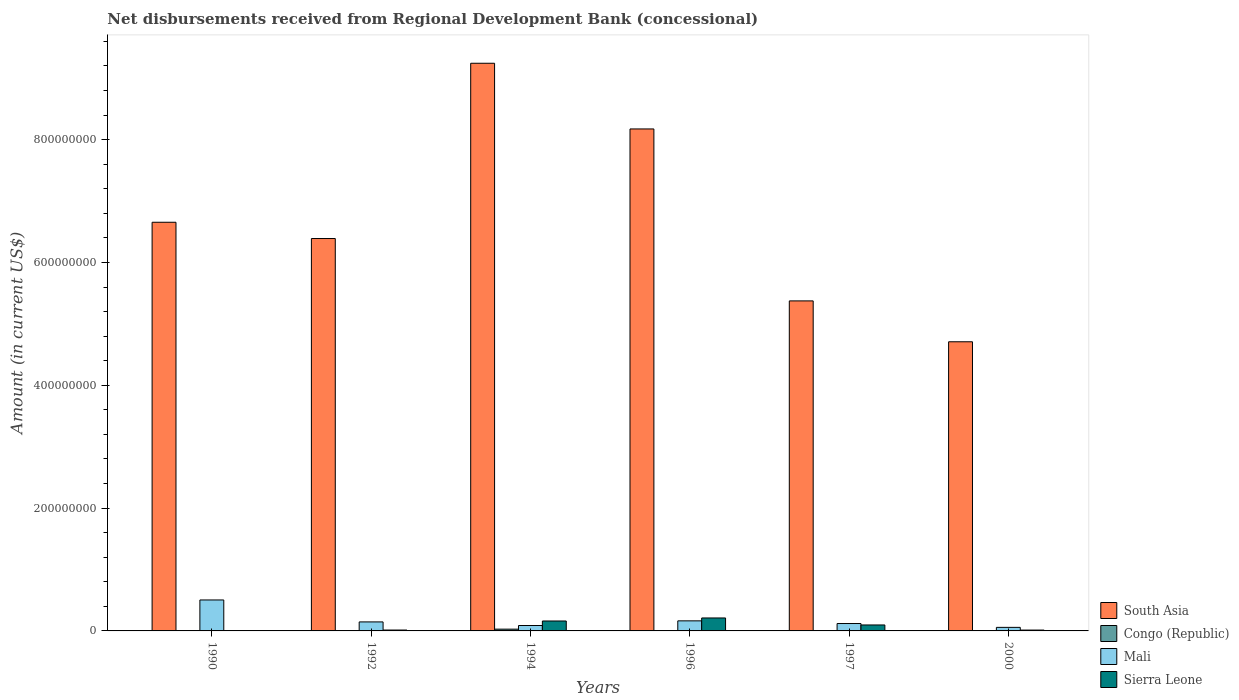Are the number of bars on each tick of the X-axis equal?
Make the answer very short. No. How many bars are there on the 3rd tick from the right?
Keep it short and to the point. 3. What is the amount of disbursements received from Regional Development Bank in South Asia in 1994?
Offer a terse response. 9.24e+08. Across all years, what is the maximum amount of disbursements received from Regional Development Bank in Congo (Republic)?
Give a very brief answer. 2.88e+06. Across all years, what is the minimum amount of disbursements received from Regional Development Bank in South Asia?
Make the answer very short. 4.71e+08. In which year was the amount of disbursements received from Regional Development Bank in Congo (Republic) maximum?
Your response must be concise. 1994. What is the total amount of disbursements received from Regional Development Bank in Mali in the graph?
Offer a terse response. 1.08e+08. What is the difference between the amount of disbursements received from Regional Development Bank in Sierra Leone in 1992 and that in 1996?
Give a very brief answer. -1.97e+07. What is the difference between the amount of disbursements received from Regional Development Bank in Mali in 1992 and the amount of disbursements received from Regional Development Bank in Congo (Republic) in 1997?
Provide a short and direct response. 1.47e+07. What is the average amount of disbursements received from Regional Development Bank in Mali per year?
Keep it short and to the point. 1.80e+07. In the year 1992, what is the difference between the amount of disbursements received from Regional Development Bank in Sierra Leone and amount of disbursements received from Regional Development Bank in South Asia?
Provide a short and direct response. -6.38e+08. In how many years, is the amount of disbursements received from Regional Development Bank in South Asia greater than 800000000 US$?
Your answer should be compact. 2. What is the ratio of the amount of disbursements received from Regional Development Bank in Sierra Leone in 1996 to that in 2000?
Provide a succinct answer. 15.21. Is the difference between the amount of disbursements received from Regional Development Bank in Sierra Leone in 1992 and 1996 greater than the difference between the amount of disbursements received from Regional Development Bank in South Asia in 1992 and 1996?
Your answer should be very brief. Yes. What is the difference between the highest and the second highest amount of disbursements received from Regional Development Bank in Sierra Leone?
Your answer should be compact. 4.92e+06. What is the difference between the highest and the lowest amount of disbursements received from Regional Development Bank in Congo (Republic)?
Provide a short and direct response. 2.88e+06. In how many years, is the amount of disbursements received from Regional Development Bank in Mali greater than the average amount of disbursements received from Regional Development Bank in Mali taken over all years?
Provide a short and direct response. 1. Is it the case that in every year, the sum of the amount of disbursements received from Regional Development Bank in South Asia and amount of disbursements received from Regional Development Bank in Congo (Republic) is greater than the amount of disbursements received from Regional Development Bank in Mali?
Ensure brevity in your answer.  Yes. How many bars are there?
Provide a short and direct response. 19. Are all the bars in the graph horizontal?
Offer a terse response. No. How many years are there in the graph?
Offer a terse response. 6. Does the graph contain any zero values?
Your response must be concise. Yes. Does the graph contain grids?
Keep it short and to the point. No. Where does the legend appear in the graph?
Your answer should be very brief. Bottom right. How many legend labels are there?
Provide a succinct answer. 4. How are the legend labels stacked?
Your answer should be compact. Vertical. What is the title of the graph?
Provide a succinct answer. Net disbursements received from Regional Development Bank (concessional). What is the label or title of the X-axis?
Offer a very short reply. Years. What is the label or title of the Y-axis?
Your answer should be very brief. Amount (in current US$). What is the Amount (in current US$) of South Asia in 1990?
Give a very brief answer. 6.65e+08. What is the Amount (in current US$) of Congo (Republic) in 1990?
Provide a succinct answer. 4.16e+05. What is the Amount (in current US$) of Mali in 1990?
Your response must be concise. 5.04e+07. What is the Amount (in current US$) in Sierra Leone in 1990?
Offer a very short reply. 0. What is the Amount (in current US$) in South Asia in 1992?
Your response must be concise. 6.39e+08. What is the Amount (in current US$) of Congo (Republic) in 1992?
Your response must be concise. 0. What is the Amount (in current US$) of Mali in 1992?
Offer a terse response. 1.47e+07. What is the Amount (in current US$) in Sierra Leone in 1992?
Provide a short and direct response. 1.43e+06. What is the Amount (in current US$) in South Asia in 1994?
Ensure brevity in your answer.  9.24e+08. What is the Amount (in current US$) of Congo (Republic) in 1994?
Ensure brevity in your answer.  2.88e+06. What is the Amount (in current US$) of Mali in 1994?
Make the answer very short. 8.81e+06. What is the Amount (in current US$) in Sierra Leone in 1994?
Provide a succinct answer. 1.62e+07. What is the Amount (in current US$) of South Asia in 1996?
Your answer should be compact. 8.17e+08. What is the Amount (in current US$) in Congo (Republic) in 1996?
Your response must be concise. 0. What is the Amount (in current US$) in Mali in 1996?
Offer a very short reply. 1.64e+07. What is the Amount (in current US$) in Sierra Leone in 1996?
Offer a very short reply. 2.11e+07. What is the Amount (in current US$) of South Asia in 1997?
Offer a terse response. 5.37e+08. What is the Amount (in current US$) of Mali in 1997?
Ensure brevity in your answer.  1.21e+07. What is the Amount (in current US$) in Sierra Leone in 1997?
Offer a very short reply. 9.70e+06. What is the Amount (in current US$) in South Asia in 2000?
Your answer should be very brief. 4.71e+08. What is the Amount (in current US$) in Congo (Republic) in 2000?
Keep it short and to the point. 0. What is the Amount (in current US$) of Mali in 2000?
Give a very brief answer. 5.78e+06. What is the Amount (in current US$) of Sierra Leone in 2000?
Provide a succinct answer. 1.39e+06. Across all years, what is the maximum Amount (in current US$) in South Asia?
Your answer should be very brief. 9.24e+08. Across all years, what is the maximum Amount (in current US$) in Congo (Republic)?
Give a very brief answer. 2.88e+06. Across all years, what is the maximum Amount (in current US$) in Mali?
Give a very brief answer. 5.04e+07. Across all years, what is the maximum Amount (in current US$) in Sierra Leone?
Offer a very short reply. 2.11e+07. Across all years, what is the minimum Amount (in current US$) in South Asia?
Keep it short and to the point. 4.71e+08. Across all years, what is the minimum Amount (in current US$) in Mali?
Your answer should be compact. 5.78e+06. What is the total Amount (in current US$) in South Asia in the graph?
Your answer should be compact. 4.05e+09. What is the total Amount (in current US$) of Congo (Republic) in the graph?
Provide a succinct answer. 3.29e+06. What is the total Amount (in current US$) of Mali in the graph?
Ensure brevity in your answer.  1.08e+08. What is the total Amount (in current US$) in Sierra Leone in the graph?
Your response must be concise. 4.98e+07. What is the difference between the Amount (in current US$) in South Asia in 1990 and that in 1992?
Give a very brief answer. 2.65e+07. What is the difference between the Amount (in current US$) of Mali in 1990 and that in 1992?
Give a very brief answer. 3.57e+07. What is the difference between the Amount (in current US$) of South Asia in 1990 and that in 1994?
Provide a short and direct response. -2.59e+08. What is the difference between the Amount (in current US$) in Congo (Republic) in 1990 and that in 1994?
Offer a terse response. -2.46e+06. What is the difference between the Amount (in current US$) of Mali in 1990 and that in 1994?
Your answer should be compact. 4.16e+07. What is the difference between the Amount (in current US$) of South Asia in 1990 and that in 1996?
Make the answer very short. -1.52e+08. What is the difference between the Amount (in current US$) in Mali in 1990 and that in 1996?
Your answer should be very brief. 3.40e+07. What is the difference between the Amount (in current US$) of South Asia in 1990 and that in 1997?
Your answer should be compact. 1.28e+08. What is the difference between the Amount (in current US$) in Mali in 1990 and that in 1997?
Make the answer very short. 3.84e+07. What is the difference between the Amount (in current US$) in South Asia in 1990 and that in 2000?
Your answer should be very brief. 1.95e+08. What is the difference between the Amount (in current US$) of Mali in 1990 and that in 2000?
Give a very brief answer. 4.46e+07. What is the difference between the Amount (in current US$) of South Asia in 1992 and that in 1994?
Your answer should be compact. -2.85e+08. What is the difference between the Amount (in current US$) of Mali in 1992 and that in 1994?
Your response must be concise. 5.86e+06. What is the difference between the Amount (in current US$) in Sierra Leone in 1992 and that in 1994?
Provide a succinct answer. -1.47e+07. What is the difference between the Amount (in current US$) of South Asia in 1992 and that in 1996?
Offer a very short reply. -1.78e+08. What is the difference between the Amount (in current US$) of Mali in 1992 and that in 1996?
Make the answer very short. -1.73e+06. What is the difference between the Amount (in current US$) of Sierra Leone in 1992 and that in 1996?
Your response must be concise. -1.97e+07. What is the difference between the Amount (in current US$) in South Asia in 1992 and that in 1997?
Ensure brevity in your answer.  1.02e+08. What is the difference between the Amount (in current US$) in Mali in 1992 and that in 1997?
Provide a short and direct response. 2.62e+06. What is the difference between the Amount (in current US$) of Sierra Leone in 1992 and that in 1997?
Ensure brevity in your answer.  -8.26e+06. What is the difference between the Amount (in current US$) of South Asia in 1992 and that in 2000?
Give a very brief answer. 1.68e+08. What is the difference between the Amount (in current US$) in Mali in 1992 and that in 2000?
Keep it short and to the point. 8.89e+06. What is the difference between the Amount (in current US$) of Sierra Leone in 1992 and that in 2000?
Provide a succinct answer. 4.40e+04. What is the difference between the Amount (in current US$) in South Asia in 1994 and that in 1996?
Provide a short and direct response. 1.07e+08. What is the difference between the Amount (in current US$) of Mali in 1994 and that in 1996?
Your answer should be very brief. -7.59e+06. What is the difference between the Amount (in current US$) of Sierra Leone in 1994 and that in 1996?
Provide a succinct answer. -4.92e+06. What is the difference between the Amount (in current US$) of South Asia in 1994 and that in 1997?
Your answer should be compact. 3.87e+08. What is the difference between the Amount (in current US$) of Mali in 1994 and that in 1997?
Provide a succinct answer. -3.24e+06. What is the difference between the Amount (in current US$) in Sierra Leone in 1994 and that in 1997?
Provide a succinct answer. 6.48e+06. What is the difference between the Amount (in current US$) of South Asia in 1994 and that in 2000?
Your response must be concise. 4.54e+08. What is the difference between the Amount (in current US$) of Mali in 1994 and that in 2000?
Provide a short and direct response. 3.03e+06. What is the difference between the Amount (in current US$) of Sierra Leone in 1994 and that in 2000?
Offer a terse response. 1.48e+07. What is the difference between the Amount (in current US$) of South Asia in 1996 and that in 1997?
Offer a terse response. 2.80e+08. What is the difference between the Amount (in current US$) in Mali in 1996 and that in 1997?
Offer a very short reply. 4.34e+06. What is the difference between the Amount (in current US$) of Sierra Leone in 1996 and that in 1997?
Make the answer very short. 1.14e+07. What is the difference between the Amount (in current US$) of South Asia in 1996 and that in 2000?
Keep it short and to the point. 3.47e+08. What is the difference between the Amount (in current US$) of Mali in 1996 and that in 2000?
Offer a very short reply. 1.06e+07. What is the difference between the Amount (in current US$) of Sierra Leone in 1996 and that in 2000?
Provide a succinct answer. 1.97e+07. What is the difference between the Amount (in current US$) of South Asia in 1997 and that in 2000?
Provide a succinct answer. 6.66e+07. What is the difference between the Amount (in current US$) in Mali in 1997 and that in 2000?
Make the answer very short. 6.28e+06. What is the difference between the Amount (in current US$) in Sierra Leone in 1997 and that in 2000?
Your answer should be very brief. 8.31e+06. What is the difference between the Amount (in current US$) in South Asia in 1990 and the Amount (in current US$) in Mali in 1992?
Ensure brevity in your answer.  6.51e+08. What is the difference between the Amount (in current US$) of South Asia in 1990 and the Amount (in current US$) of Sierra Leone in 1992?
Provide a succinct answer. 6.64e+08. What is the difference between the Amount (in current US$) in Congo (Republic) in 1990 and the Amount (in current US$) in Mali in 1992?
Offer a very short reply. -1.43e+07. What is the difference between the Amount (in current US$) of Congo (Republic) in 1990 and the Amount (in current US$) of Sierra Leone in 1992?
Your answer should be very brief. -1.02e+06. What is the difference between the Amount (in current US$) in Mali in 1990 and the Amount (in current US$) in Sierra Leone in 1992?
Your response must be concise. 4.90e+07. What is the difference between the Amount (in current US$) in South Asia in 1990 and the Amount (in current US$) in Congo (Republic) in 1994?
Give a very brief answer. 6.63e+08. What is the difference between the Amount (in current US$) in South Asia in 1990 and the Amount (in current US$) in Mali in 1994?
Provide a short and direct response. 6.57e+08. What is the difference between the Amount (in current US$) of South Asia in 1990 and the Amount (in current US$) of Sierra Leone in 1994?
Provide a short and direct response. 6.49e+08. What is the difference between the Amount (in current US$) in Congo (Republic) in 1990 and the Amount (in current US$) in Mali in 1994?
Make the answer very short. -8.39e+06. What is the difference between the Amount (in current US$) in Congo (Republic) in 1990 and the Amount (in current US$) in Sierra Leone in 1994?
Make the answer very short. -1.58e+07. What is the difference between the Amount (in current US$) of Mali in 1990 and the Amount (in current US$) of Sierra Leone in 1994?
Ensure brevity in your answer.  3.42e+07. What is the difference between the Amount (in current US$) of South Asia in 1990 and the Amount (in current US$) of Mali in 1996?
Provide a short and direct response. 6.49e+08. What is the difference between the Amount (in current US$) in South Asia in 1990 and the Amount (in current US$) in Sierra Leone in 1996?
Your answer should be compact. 6.44e+08. What is the difference between the Amount (in current US$) of Congo (Republic) in 1990 and the Amount (in current US$) of Mali in 1996?
Make the answer very short. -1.60e+07. What is the difference between the Amount (in current US$) of Congo (Republic) in 1990 and the Amount (in current US$) of Sierra Leone in 1996?
Your response must be concise. -2.07e+07. What is the difference between the Amount (in current US$) in Mali in 1990 and the Amount (in current US$) in Sierra Leone in 1996?
Provide a short and direct response. 2.93e+07. What is the difference between the Amount (in current US$) in South Asia in 1990 and the Amount (in current US$) in Mali in 1997?
Your response must be concise. 6.53e+08. What is the difference between the Amount (in current US$) in South Asia in 1990 and the Amount (in current US$) in Sierra Leone in 1997?
Your answer should be very brief. 6.56e+08. What is the difference between the Amount (in current US$) in Congo (Republic) in 1990 and the Amount (in current US$) in Mali in 1997?
Ensure brevity in your answer.  -1.16e+07. What is the difference between the Amount (in current US$) of Congo (Republic) in 1990 and the Amount (in current US$) of Sierra Leone in 1997?
Offer a very short reply. -9.28e+06. What is the difference between the Amount (in current US$) of Mali in 1990 and the Amount (in current US$) of Sierra Leone in 1997?
Your answer should be compact. 4.07e+07. What is the difference between the Amount (in current US$) in South Asia in 1990 and the Amount (in current US$) in Mali in 2000?
Provide a succinct answer. 6.60e+08. What is the difference between the Amount (in current US$) in South Asia in 1990 and the Amount (in current US$) in Sierra Leone in 2000?
Keep it short and to the point. 6.64e+08. What is the difference between the Amount (in current US$) of Congo (Republic) in 1990 and the Amount (in current US$) of Mali in 2000?
Your answer should be very brief. -5.36e+06. What is the difference between the Amount (in current US$) of Congo (Republic) in 1990 and the Amount (in current US$) of Sierra Leone in 2000?
Give a very brief answer. -9.71e+05. What is the difference between the Amount (in current US$) of Mali in 1990 and the Amount (in current US$) of Sierra Leone in 2000?
Offer a very short reply. 4.90e+07. What is the difference between the Amount (in current US$) of South Asia in 1992 and the Amount (in current US$) of Congo (Republic) in 1994?
Your answer should be very brief. 6.36e+08. What is the difference between the Amount (in current US$) in South Asia in 1992 and the Amount (in current US$) in Mali in 1994?
Make the answer very short. 6.30e+08. What is the difference between the Amount (in current US$) in South Asia in 1992 and the Amount (in current US$) in Sierra Leone in 1994?
Your answer should be compact. 6.23e+08. What is the difference between the Amount (in current US$) in Mali in 1992 and the Amount (in current US$) in Sierra Leone in 1994?
Offer a terse response. -1.51e+06. What is the difference between the Amount (in current US$) of South Asia in 1992 and the Amount (in current US$) of Mali in 1996?
Offer a terse response. 6.23e+08. What is the difference between the Amount (in current US$) of South Asia in 1992 and the Amount (in current US$) of Sierra Leone in 1996?
Give a very brief answer. 6.18e+08. What is the difference between the Amount (in current US$) in Mali in 1992 and the Amount (in current US$) in Sierra Leone in 1996?
Make the answer very short. -6.43e+06. What is the difference between the Amount (in current US$) in South Asia in 1992 and the Amount (in current US$) in Mali in 1997?
Your answer should be compact. 6.27e+08. What is the difference between the Amount (in current US$) of South Asia in 1992 and the Amount (in current US$) of Sierra Leone in 1997?
Your answer should be very brief. 6.29e+08. What is the difference between the Amount (in current US$) of Mali in 1992 and the Amount (in current US$) of Sierra Leone in 1997?
Your answer should be compact. 4.97e+06. What is the difference between the Amount (in current US$) in South Asia in 1992 and the Amount (in current US$) in Mali in 2000?
Your answer should be compact. 6.33e+08. What is the difference between the Amount (in current US$) of South Asia in 1992 and the Amount (in current US$) of Sierra Leone in 2000?
Make the answer very short. 6.38e+08. What is the difference between the Amount (in current US$) in Mali in 1992 and the Amount (in current US$) in Sierra Leone in 2000?
Ensure brevity in your answer.  1.33e+07. What is the difference between the Amount (in current US$) of South Asia in 1994 and the Amount (in current US$) of Mali in 1996?
Your response must be concise. 9.08e+08. What is the difference between the Amount (in current US$) of South Asia in 1994 and the Amount (in current US$) of Sierra Leone in 1996?
Offer a terse response. 9.03e+08. What is the difference between the Amount (in current US$) in Congo (Republic) in 1994 and the Amount (in current US$) in Mali in 1996?
Offer a very short reply. -1.35e+07. What is the difference between the Amount (in current US$) of Congo (Republic) in 1994 and the Amount (in current US$) of Sierra Leone in 1996?
Give a very brief answer. -1.82e+07. What is the difference between the Amount (in current US$) of Mali in 1994 and the Amount (in current US$) of Sierra Leone in 1996?
Make the answer very short. -1.23e+07. What is the difference between the Amount (in current US$) in South Asia in 1994 and the Amount (in current US$) in Mali in 1997?
Your answer should be compact. 9.12e+08. What is the difference between the Amount (in current US$) in South Asia in 1994 and the Amount (in current US$) in Sierra Leone in 1997?
Your response must be concise. 9.15e+08. What is the difference between the Amount (in current US$) in Congo (Republic) in 1994 and the Amount (in current US$) in Mali in 1997?
Ensure brevity in your answer.  -9.17e+06. What is the difference between the Amount (in current US$) of Congo (Republic) in 1994 and the Amount (in current US$) of Sierra Leone in 1997?
Give a very brief answer. -6.82e+06. What is the difference between the Amount (in current US$) of Mali in 1994 and the Amount (in current US$) of Sierra Leone in 1997?
Your response must be concise. -8.88e+05. What is the difference between the Amount (in current US$) in South Asia in 1994 and the Amount (in current US$) in Mali in 2000?
Make the answer very short. 9.19e+08. What is the difference between the Amount (in current US$) of South Asia in 1994 and the Amount (in current US$) of Sierra Leone in 2000?
Give a very brief answer. 9.23e+08. What is the difference between the Amount (in current US$) in Congo (Republic) in 1994 and the Amount (in current US$) in Mali in 2000?
Ensure brevity in your answer.  -2.90e+06. What is the difference between the Amount (in current US$) of Congo (Republic) in 1994 and the Amount (in current US$) of Sierra Leone in 2000?
Your answer should be compact. 1.49e+06. What is the difference between the Amount (in current US$) in Mali in 1994 and the Amount (in current US$) in Sierra Leone in 2000?
Your response must be concise. 7.42e+06. What is the difference between the Amount (in current US$) in South Asia in 1996 and the Amount (in current US$) in Mali in 1997?
Ensure brevity in your answer.  8.05e+08. What is the difference between the Amount (in current US$) in South Asia in 1996 and the Amount (in current US$) in Sierra Leone in 1997?
Your response must be concise. 8.08e+08. What is the difference between the Amount (in current US$) of Mali in 1996 and the Amount (in current US$) of Sierra Leone in 1997?
Provide a succinct answer. 6.70e+06. What is the difference between the Amount (in current US$) of South Asia in 1996 and the Amount (in current US$) of Mali in 2000?
Offer a very short reply. 8.12e+08. What is the difference between the Amount (in current US$) of South Asia in 1996 and the Amount (in current US$) of Sierra Leone in 2000?
Keep it short and to the point. 8.16e+08. What is the difference between the Amount (in current US$) in Mali in 1996 and the Amount (in current US$) in Sierra Leone in 2000?
Give a very brief answer. 1.50e+07. What is the difference between the Amount (in current US$) in South Asia in 1997 and the Amount (in current US$) in Mali in 2000?
Your answer should be compact. 5.32e+08. What is the difference between the Amount (in current US$) of South Asia in 1997 and the Amount (in current US$) of Sierra Leone in 2000?
Give a very brief answer. 5.36e+08. What is the difference between the Amount (in current US$) of Mali in 1997 and the Amount (in current US$) of Sierra Leone in 2000?
Give a very brief answer. 1.07e+07. What is the average Amount (in current US$) in South Asia per year?
Keep it short and to the point. 6.76e+08. What is the average Amount (in current US$) in Congo (Republic) per year?
Your answer should be compact. 5.49e+05. What is the average Amount (in current US$) of Mali per year?
Offer a very short reply. 1.80e+07. What is the average Amount (in current US$) in Sierra Leone per year?
Make the answer very short. 8.30e+06. In the year 1990, what is the difference between the Amount (in current US$) in South Asia and Amount (in current US$) in Congo (Republic)?
Offer a terse response. 6.65e+08. In the year 1990, what is the difference between the Amount (in current US$) in South Asia and Amount (in current US$) in Mali?
Offer a terse response. 6.15e+08. In the year 1990, what is the difference between the Amount (in current US$) in Congo (Republic) and Amount (in current US$) in Mali?
Provide a succinct answer. -5.00e+07. In the year 1992, what is the difference between the Amount (in current US$) of South Asia and Amount (in current US$) of Mali?
Provide a short and direct response. 6.24e+08. In the year 1992, what is the difference between the Amount (in current US$) of South Asia and Amount (in current US$) of Sierra Leone?
Give a very brief answer. 6.38e+08. In the year 1992, what is the difference between the Amount (in current US$) of Mali and Amount (in current US$) of Sierra Leone?
Offer a terse response. 1.32e+07. In the year 1994, what is the difference between the Amount (in current US$) in South Asia and Amount (in current US$) in Congo (Republic)?
Offer a very short reply. 9.22e+08. In the year 1994, what is the difference between the Amount (in current US$) in South Asia and Amount (in current US$) in Mali?
Offer a very short reply. 9.16e+08. In the year 1994, what is the difference between the Amount (in current US$) in South Asia and Amount (in current US$) in Sierra Leone?
Provide a short and direct response. 9.08e+08. In the year 1994, what is the difference between the Amount (in current US$) of Congo (Republic) and Amount (in current US$) of Mali?
Provide a succinct answer. -5.93e+06. In the year 1994, what is the difference between the Amount (in current US$) of Congo (Republic) and Amount (in current US$) of Sierra Leone?
Your answer should be compact. -1.33e+07. In the year 1994, what is the difference between the Amount (in current US$) of Mali and Amount (in current US$) of Sierra Leone?
Offer a very short reply. -7.37e+06. In the year 1996, what is the difference between the Amount (in current US$) in South Asia and Amount (in current US$) in Mali?
Offer a very short reply. 8.01e+08. In the year 1996, what is the difference between the Amount (in current US$) in South Asia and Amount (in current US$) in Sierra Leone?
Your answer should be compact. 7.96e+08. In the year 1996, what is the difference between the Amount (in current US$) of Mali and Amount (in current US$) of Sierra Leone?
Provide a succinct answer. -4.71e+06. In the year 1997, what is the difference between the Amount (in current US$) in South Asia and Amount (in current US$) in Mali?
Your answer should be very brief. 5.25e+08. In the year 1997, what is the difference between the Amount (in current US$) of South Asia and Amount (in current US$) of Sierra Leone?
Make the answer very short. 5.28e+08. In the year 1997, what is the difference between the Amount (in current US$) in Mali and Amount (in current US$) in Sierra Leone?
Provide a short and direct response. 2.36e+06. In the year 2000, what is the difference between the Amount (in current US$) in South Asia and Amount (in current US$) in Mali?
Provide a short and direct response. 4.65e+08. In the year 2000, what is the difference between the Amount (in current US$) of South Asia and Amount (in current US$) of Sierra Leone?
Provide a succinct answer. 4.69e+08. In the year 2000, what is the difference between the Amount (in current US$) in Mali and Amount (in current US$) in Sierra Leone?
Your response must be concise. 4.39e+06. What is the ratio of the Amount (in current US$) in South Asia in 1990 to that in 1992?
Ensure brevity in your answer.  1.04. What is the ratio of the Amount (in current US$) in Mali in 1990 to that in 1992?
Provide a succinct answer. 3.44. What is the ratio of the Amount (in current US$) of South Asia in 1990 to that in 1994?
Ensure brevity in your answer.  0.72. What is the ratio of the Amount (in current US$) of Congo (Republic) in 1990 to that in 1994?
Your answer should be very brief. 0.14. What is the ratio of the Amount (in current US$) of Mali in 1990 to that in 1994?
Your answer should be very brief. 5.72. What is the ratio of the Amount (in current US$) in South Asia in 1990 to that in 1996?
Your response must be concise. 0.81. What is the ratio of the Amount (in current US$) of Mali in 1990 to that in 1996?
Ensure brevity in your answer.  3.07. What is the ratio of the Amount (in current US$) in South Asia in 1990 to that in 1997?
Give a very brief answer. 1.24. What is the ratio of the Amount (in current US$) of Mali in 1990 to that in 1997?
Your response must be concise. 4.18. What is the ratio of the Amount (in current US$) of South Asia in 1990 to that in 2000?
Your answer should be compact. 1.41. What is the ratio of the Amount (in current US$) of Mali in 1990 to that in 2000?
Provide a short and direct response. 8.73. What is the ratio of the Amount (in current US$) of South Asia in 1992 to that in 1994?
Offer a terse response. 0.69. What is the ratio of the Amount (in current US$) in Mali in 1992 to that in 1994?
Offer a very short reply. 1.67. What is the ratio of the Amount (in current US$) in Sierra Leone in 1992 to that in 1994?
Offer a terse response. 0.09. What is the ratio of the Amount (in current US$) of South Asia in 1992 to that in 1996?
Your answer should be compact. 0.78. What is the ratio of the Amount (in current US$) in Mali in 1992 to that in 1996?
Ensure brevity in your answer.  0.89. What is the ratio of the Amount (in current US$) of Sierra Leone in 1992 to that in 1996?
Provide a short and direct response. 0.07. What is the ratio of the Amount (in current US$) of South Asia in 1992 to that in 1997?
Give a very brief answer. 1.19. What is the ratio of the Amount (in current US$) of Mali in 1992 to that in 1997?
Make the answer very short. 1.22. What is the ratio of the Amount (in current US$) of Sierra Leone in 1992 to that in 1997?
Give a very brief answer. 0.15. What is the ratio of the Amount (in current US$) of South Asia in 1992 to that in 2000?
Ensure brevity in your answer.  1.36. What is the ratio of the Amount (in current US$) of Mali in 1992 to that in 2000?
Keep it short and to the point. 2.54. What is the ratio of the Amount (in current US$) of Sierra Leone in 1992 to that in 2000?
Keep it short and to the point. 1.03. What is the ratio of the Amount (in current US$) of South Asia in 1994 to that in 1996?
Provide a short and direct response. 1.13. What is the ratio of the Amount (in current US$) in Mali in 1994 to that in 1996?
Offer a very short reply. 0.54. What is the ratio of the Amount (in current US$) of Sierra Leone in 1994 to that in 1996?
Give a very brief answer. 0.77. What is the ratio of the Amount (in current US$) of South Asia in 1994 to that in 1997?
Provide a short and direct response. 1.72. What is the ratio of the Amount (in current US$) in Mali in 1994 to that in 1997?
Give a very brief answer. 0.73. What is the ratio of the Amount (in current US$) in Sierra Leone in 1994 to that in 1997?
Ensure brevity in your answer.  1.67. What is the ratio of the Amount (in current US$) in South Asia in 1994 to that in 2000?
Provide a succinct answer. 1.96. What is the ratio of the Amount (in current US$) in Mali in 1994 to that in 2000?
Give a very brief answer. 1.52. What is the ratio of the Amount (in current US$) of Sierra Leone in 1994 to that in 2000?
Offer a terse response. 11.66. What is the ratio of the Amount (in current US$) of South Asia in 1996 to that in 1997?
Make the answer very short. 1.52. What is the ratio of the Amount (in current US$) in Mali in 1996 to that in 1997?
Provide a succinct answer. 1.36. What is the ratio of the Amount (in current US$) of Sierra Leone in 1996 to that in 1997?
Keep it short and to the point. 2.18. What is the ratio of the Amount (in current US$) in South Asia in 1996 to that in 2000?
Your answer should be compact. 1.74. What is the ratio of the Amount (in current US$) in Mali in 1996 to that in 2000?
Your answer should be very brief. 2.84. What is the ratio of the Amount (in current US$) of Sierra Leone in 1996 to that in 2000?
Your answer should be very brief. 15.21. What is the ratio of the Amount (in current US$) of South Asia in 1997 to that in 2000?
Provide a succinct answer. 1.14. What is the ratio of the Amount (in current US$) in Mali in 1997 to that in 2000?
Offer a very short reply. 2.09. What is the ratio of the Amount (in current US$) of Sierra Leone in 1997 to that in 2000?
Your answer should be compact. 6.99. What is the difference between the highest and the second highest Amount (in current US$) of South Asia?
Provide a succinct answer. 1.07e+08. What is the difference between the highest and the second highest Amount (in current US$) of Mali?
Provide a succinct answer. 3.40e+07. What is the difference between the highest and the second highest Amount (in current US$) of Sierra Leone?
Provide a succinct answer. 4.92e+06. What is the difference between the highest and the lowest Amount (in current US$) in South Asia?
Your answer should be very brief. 4.54e+08. What is the difference between the highest and the lowest Amount (in current US$) in Congo (Republic)?
Your answer should be compact. 2.88e+06. What is the difference between the highest and the lowest Amount (in current US$) of Mali?
Provide a short and direct response. 4.46e+07. What is the difference between the highest and the lowest Amount (in current US$) of Sierra Leone?
Your answer should be compact. 2.11e+07. 